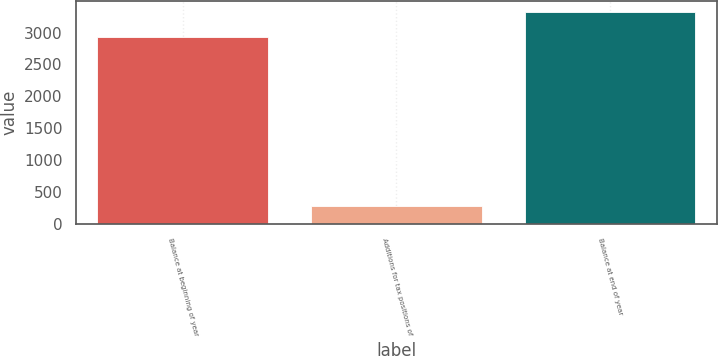Convert chart. <chart><loc_0><loc_0><loc_500><loc_500><bar_chart><fcel>Balance at beginning of year<fcel>Additions for tax positions of<fcel>Balance at end of year<nl><fcel>2924<fcel>277<fcel>3329<nl></chart> 